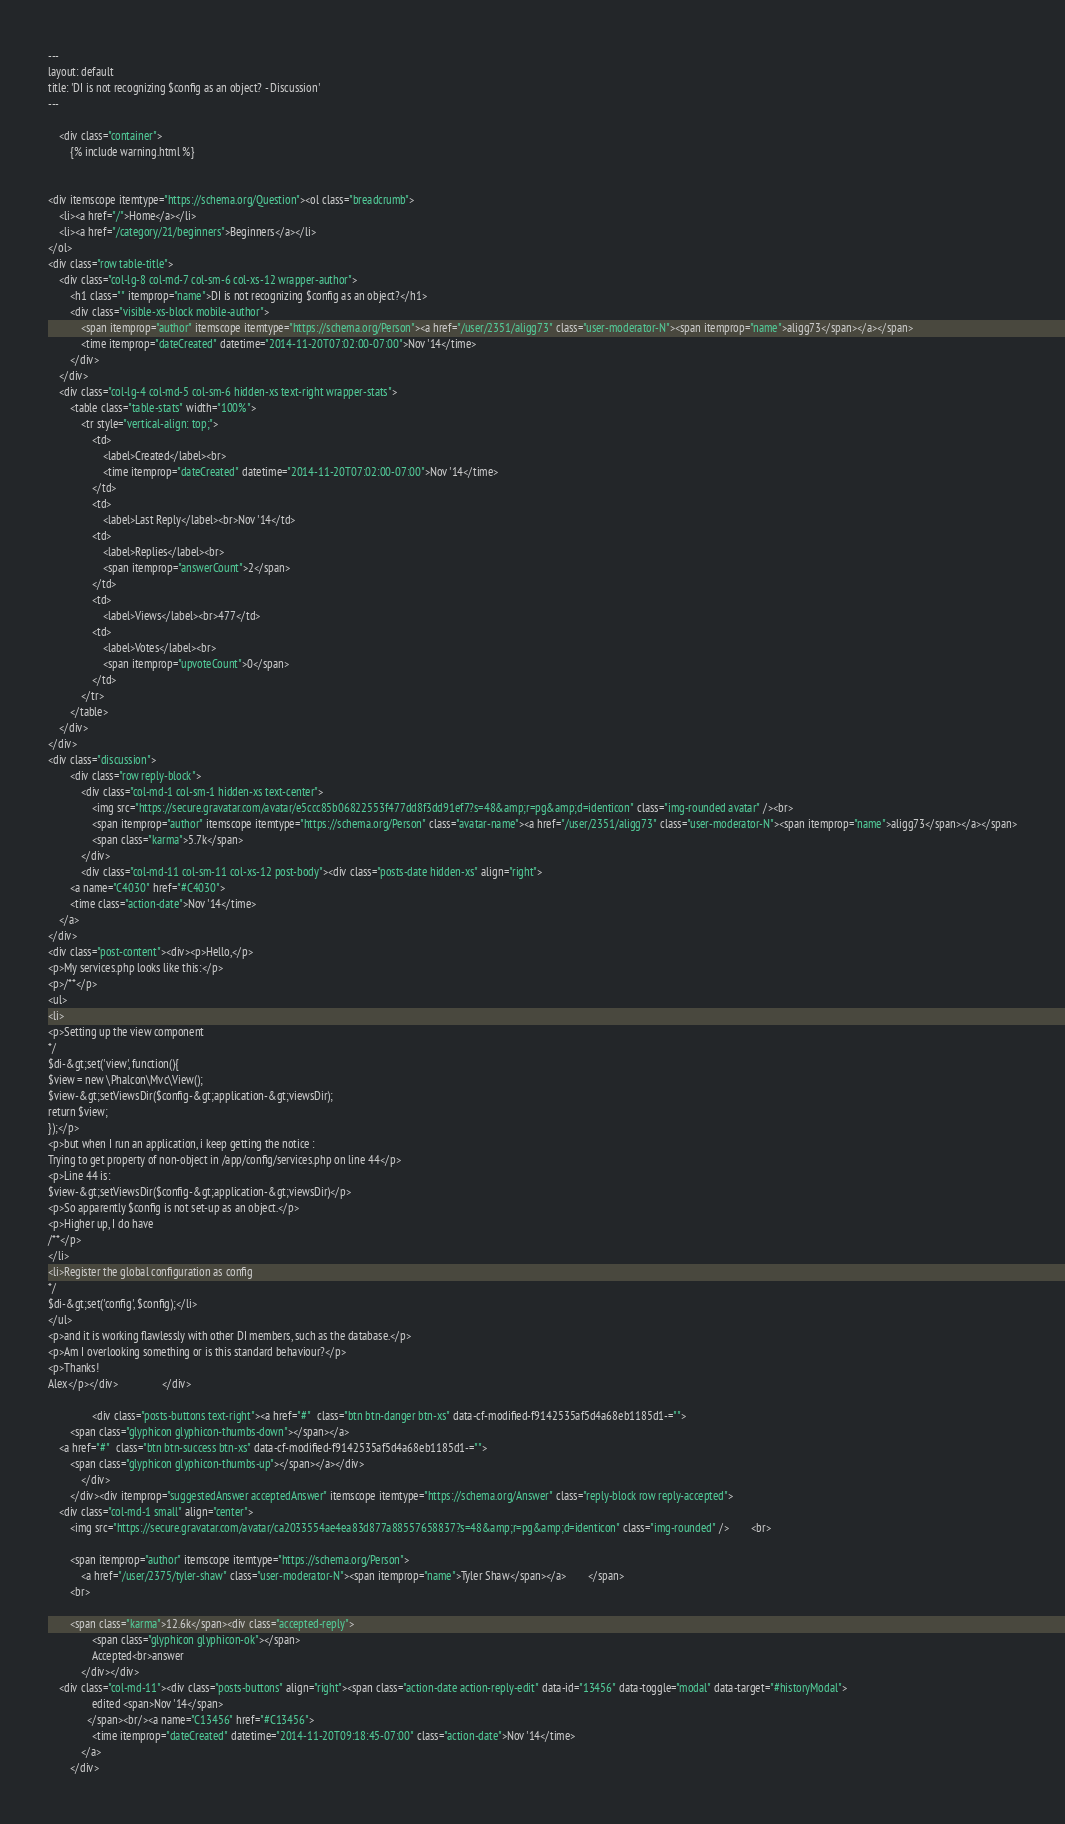<code> <loc_0><loc_0><loc_500><loc_500><_HTML_>---
layout: default
title: 'DI is not recognizing $config as an object? - Discussion'
---

    <div class="container">
        {% include warning.html %}


<div itemscope itemtype="https://schema.org/Question"><ol class="breadcrumb">
    <li><a href="/">Home</a></li>
    <li><a href="/category/21/beginners">Beginners</a></li>
</ol>
<div class="row table-title">
    <div class="col-lg-8 col-md-7 col-sm-6 col-xs-12 wrapper-author">
        <h1 class="" itemprop="name">DI is not recognizing $config as an object?</h1>
        <div class="visible-xs-block mobile-author">
            <span itemprop="author" itemscope itemtype="https://schema.org/Person"><a href="/user/2351/aligg73" class="user-moderator-N"><span itemprop="name">aligg73</span></a></span>
            <time itemprop="dateCreated" datetime="2014-11-20T07:02:00-07:00">Nov '14</time>
        </div>
    </div>
    <div class="col-lg-4 col-md-5 col-sm-6 hidden-xs text-right wrapper-stats">
        <table class="table-stats" width="100%">
            <tr style="vertical-align: top;">
                <td>
                    <label>Created</label><br>
                    <time itemprop="dateCreated" datetime="2014-11-20T07:02:00-07:00">Nov '14</time>
                </td>
                <td>
                    <label>Last Reply</label><br>Nov '14</td>
                <td>
                    <label>Replies</label><br>
                    <span itemprop="answerCount">2</span>
                </td>
                <td>
                    <label>Views</label><br>477</td>
                <td>
                    <label>Votes</label><br>
                    <span itemprop="upvoteCount">0</span>
                </td>
            </tr>
        </table>
    </div>
</div>
<div class="discussion">
        <div class="row reply-block">
            <div class="col-md-1 col-sm-1 hidden-xs text-center">
                <img src="https://secure.gravatar.com/avatar/e5ccc85b06822553f477dd8f3dd91ef7?s=48&amp;r=pg&amp;d=identicon" class="img-rounded avatar" /><br>
                <span itemprop="author" itemscope itemtype="https://schema.org/Person" class="avatar-name"><a href="/user/2351/aligg73" class="user-moderator-N"><span itemprop="name">aligg73</span></a></span>
                <span class="karma">5.7k</span>
            </div>
            <div class="col-md-11 col-sm-11 col-xs-12 post-body"><div class="posts-date hidden-xs" align="right">
        <a name="C4030" href="#C4030">
        <time class="action-date">Nov '14</time>
    </a>
</div>
<div class="post-content"><div><p>Hello,</p>
<p>My services.php looks like this:</p>
<p>/**</p>
<ul>
<li>
<p>Setting up the view component
*/
$di-&gt;set('view', function(){
$view = new \Phalcon\Mvc\View();
$view-&gt;setViewsDir($config-&gt;application-&gt;viewsDir);
return $view;
});</p>
<p>but when I run an application, i keep getting the notice :
Trying to get property of non-object in /app/config/services.php on line 44</p>
<p>Line 44 is:
$view-&gt;setViewsDir($config-&gt;application-&gt;viewsDir)</p>
<p>So apparently $config is not set-up as an object.</p>
<p>Higher up, I do have
/**</p>
</li>
<li>Register the global configuration as config
*/
$di-&gt;set('config', $config);</li>
</ul>
<p>and it is working flawlessly with other DI members, such as the database.</p>
<p>Am I overlooking something or is this standard behaviour?</p>
<p>Thanks!
Alex</p></div>                </div>

                <div class="posts-buttons text-right"><a href="#"  class="btn btn-danger btn-xs" data-cf-modified-f9142535af5d4a68eb1185d1-="">
        <span class="glyphicon glyphicon-thumbs-down"></span></a>
    <a href="#"  class="btn btn-success btn-xs" data-cf-modified-f9142535af5d4a68eb1185d1-="">
        <span class="glyphicon glyphicon-thumbs-up"></span></a></div>
            </div>
        </div><div itemprop="suggestedAnswer acceptedAnswer" itemscope itemtype="https://schema.org/Answer" class="reply-block row reply-accepted">
    <div class="col-md-1 small" align="center">
        <img src="https://secure.gravatar.com/avatar/ca2033554ae4ea83d877a88557658837?s=48&amp;r=pg&amp;d=identicon" class="img-rounded" />        <br>

        <span itemprop="author" itemscope itemtype="https://schema.org/Person">
            <a href="/user/2375/tyler-shaw" class="user-moderator-N"><span itemprop="name">Tyler Shaw</span></a>        </span>
        <br>

        <span class="karma">12.6k</span><div class="accepted-reply">
                <span class="glyphicon glyphicon-ok"></span>
                Accepted<br>answer
            </div></div>
    <div class="col-md-11"><div class="posts-buttons" align="right"><span class="action-date action-reply-edit" data-id="13456" data-toggle="modal" data-target="#historyModal">
                edited <span>Nov '14</span>
              </span><br/><a name="C13456" href="#C13456">
                <time itemprop="dateCreated" datetime="2014-11-20T09:18:45-07:00" class="action-date">Nov '14</time>
            </a>
        </div></code> 